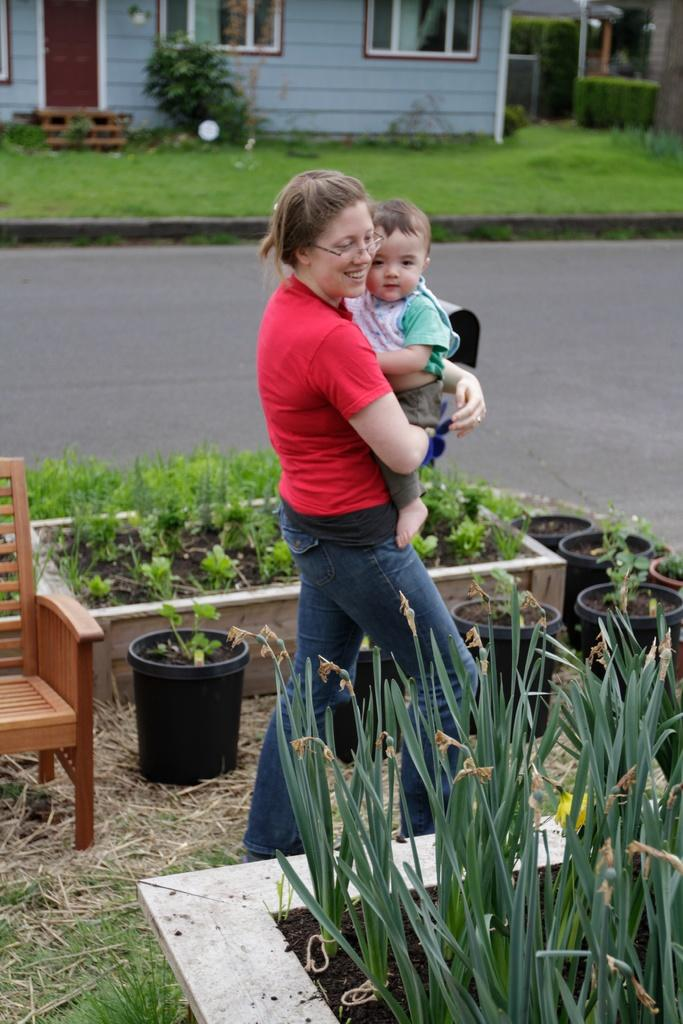Who is the main subject in the image? There is a woman in the image. What is the woman doing in the image? The woman is holding a baby. What can be seen in the background of the image? There is a road, a house, grass, and a plant visible in the image. What type of furniture is present in the image? There is a chair in the image. Can you see any ghosts interacting with the woman and baby in the image? No, there are no ghosts present in the image. What type of expert is providing advice to the woman in the image? There is no expert present in the image; it only shows a woman holding a baby. 